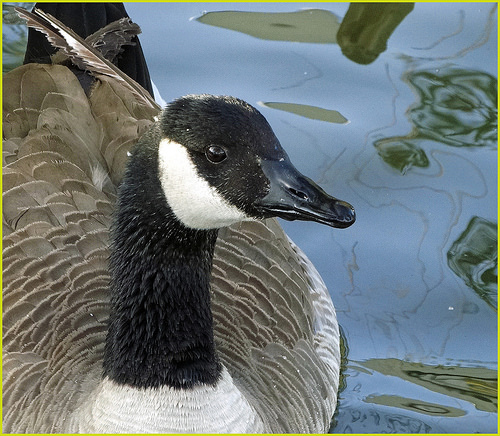<image>
Is the goose on the water? Yes. Looking at the image, I can see the goose is positioned on top of the water, with the water providing support. 